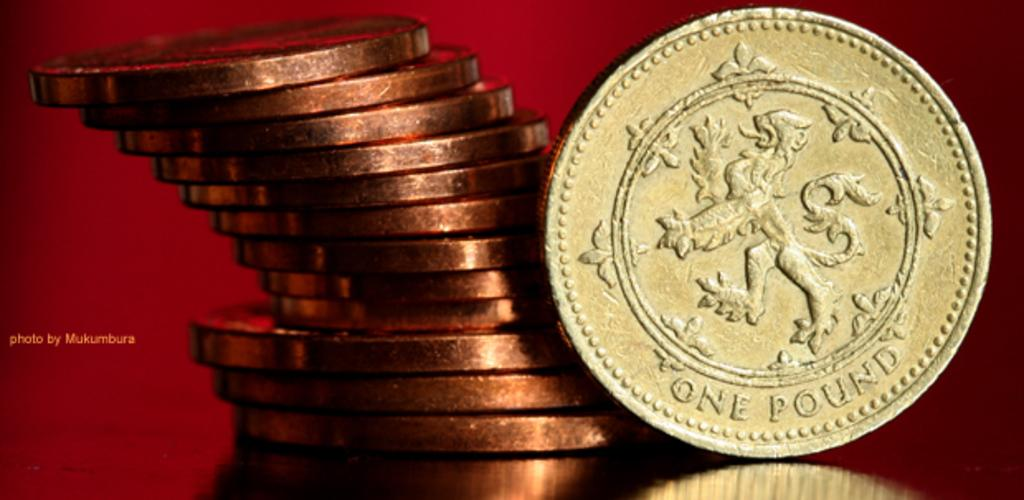<image>
Describe the image concisely. A coin that is labeled with the denomination of one pound. 